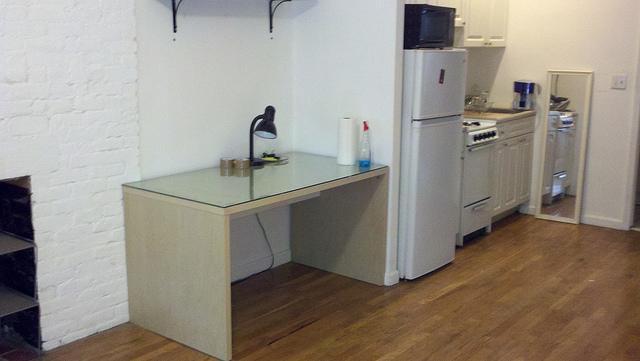How many doors does the fridge have?
Give a very brief answer. 2. How many hot dogs are in this picture?
Give a very brief answer. 0. 